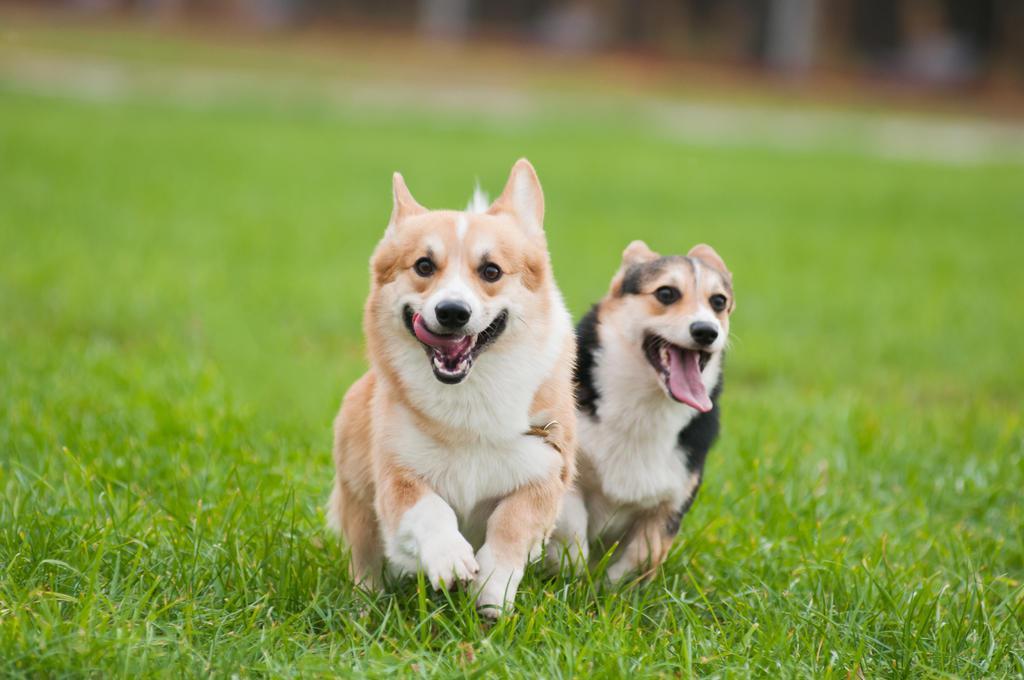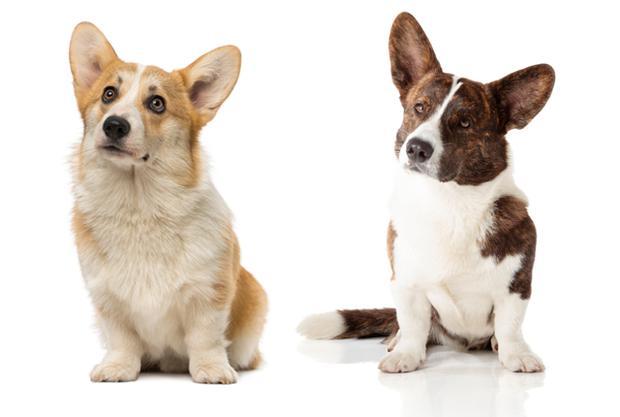The first image is the image on the left, the second image is the image on the right. Assess this claim about the two images: "An image shows two short-legged dogs running across a grassy area.". Correct or not? Answer yes or no. Yes. The first image is the image on the left, the second image is the image on the right. Given the left and right images, does the statement "Two of the corgis are running with their mouths hanging open, the other two are sitting facing towards the camera." hold true? Answer yes or no. Yes. 